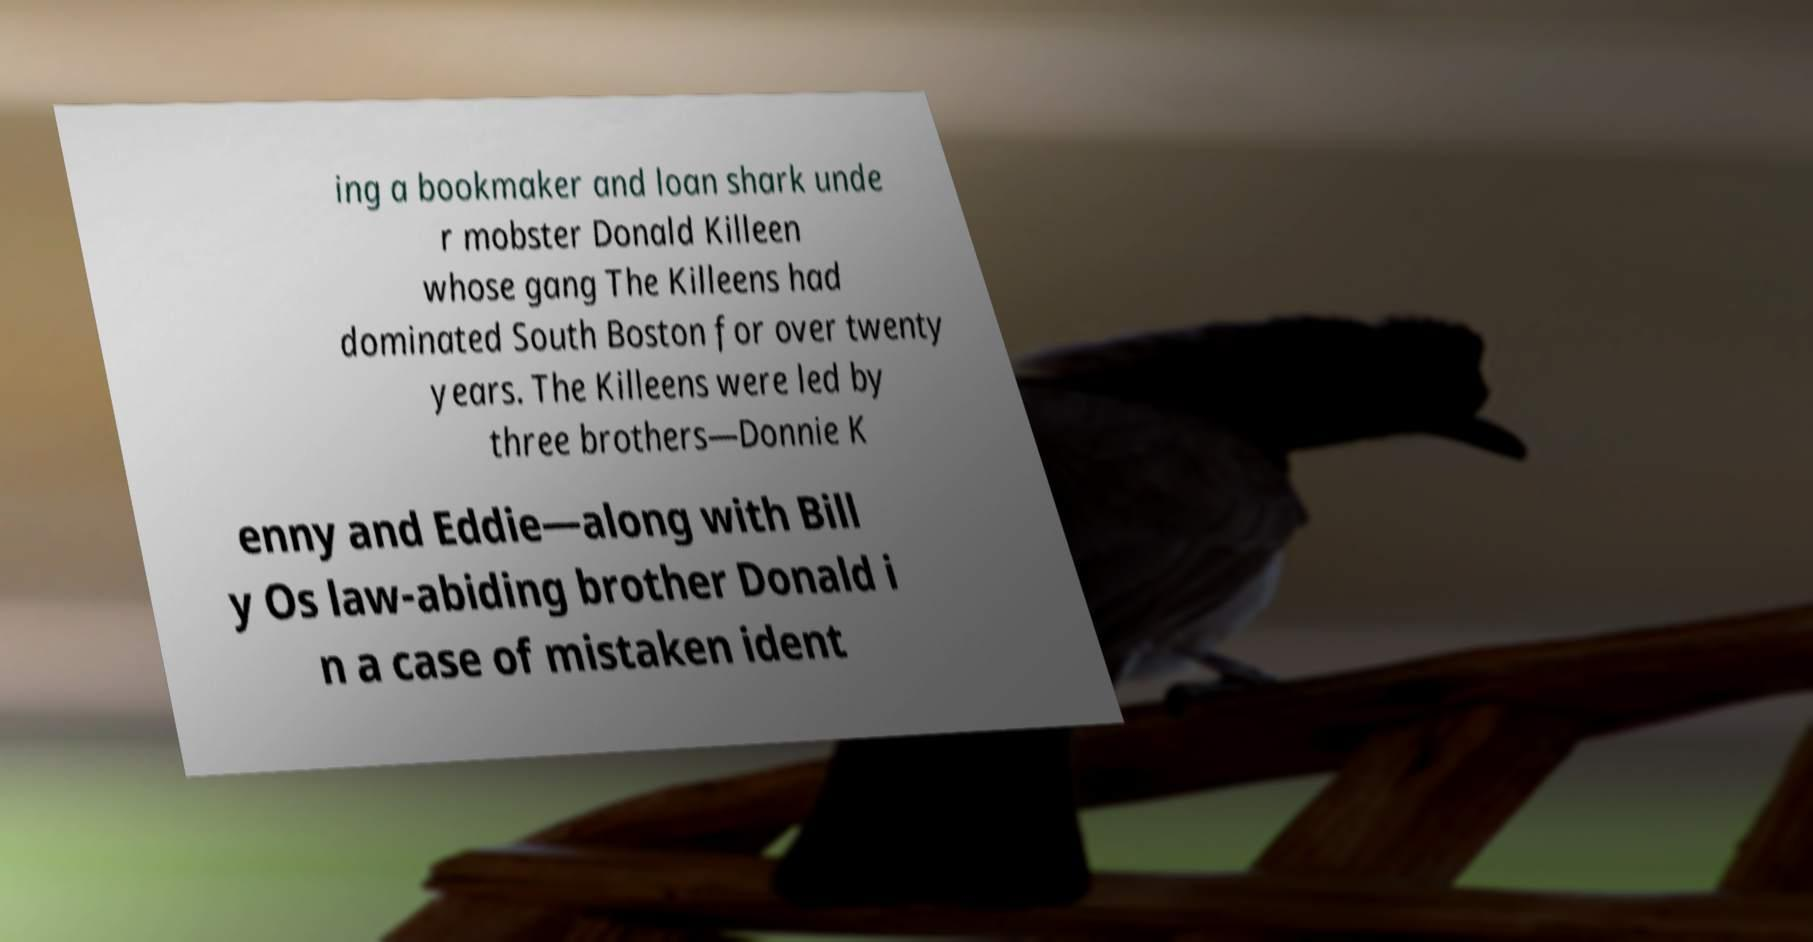There's text embedded in this image that I need extracted. Can you transcribe it verbatim? ing a bookmaker and loan shark unde r mobster Donald Killeen whose gang The Killeens had dominated South Boston for over twenty years. The Killeens were led by three brothers—Donnie K enny and Eddie—along with Bill y Os law-abiding brother Donald i n a case of mistaken ident 